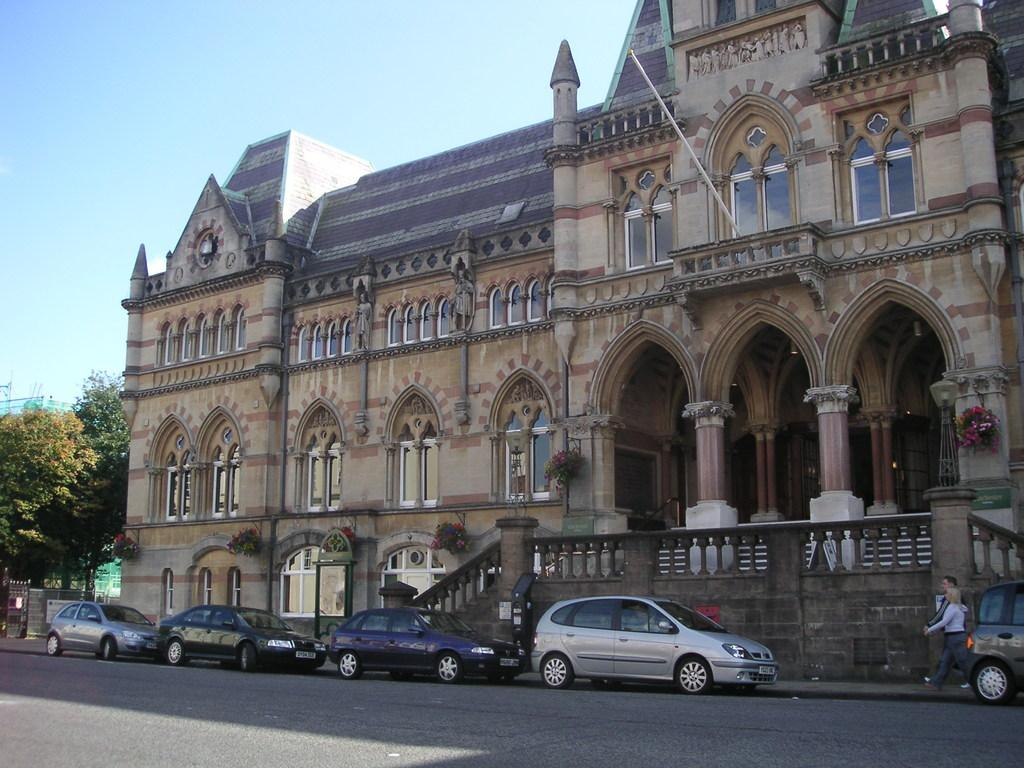What can be seen on the road in the image? There are cars on the road in the image. What type of structure is visible in the image? There is a building with windows in the image. What natural elements are present in the image? Trees are present in the image. What architectural features can be seen in the image? There are pillars in the image. What are the two persons in the image doing? Two persons are walking on a footpath in the image. What is visible in the background of the image? The sky is visible in the background of the image. What type of animal can be seen swimming in the image? There is no animal present in the image, let alone swimming. What kind of ship is visible in the image? There is no ship present in the image. 